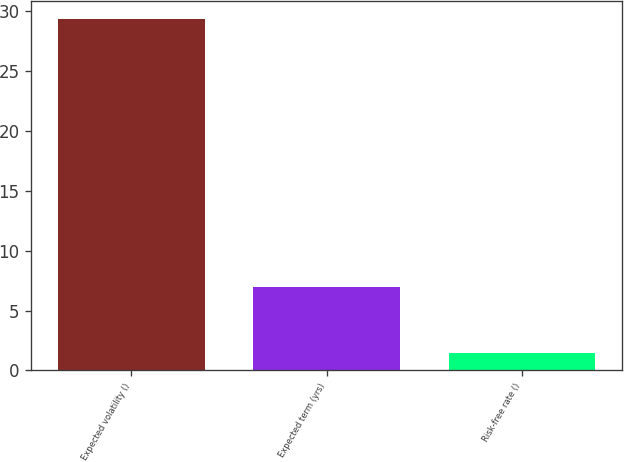Convert chart to OTSL. <chart><loc_0><loc_0><loc_500><loc_500><bar_chart><fcel>Expected volatility ()<fcel>Expected term (yrs)<fcel>Risk-free rate ()<nl><fcel>29.4<fcel>7<fcel>1.5<nl></chart> 